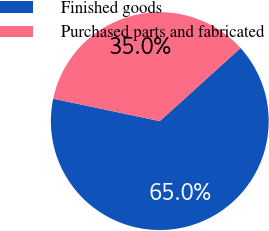Convert chart. <chart><loc_0><loc_0><loc_500><loc_500><pie_chart><fcel>Finished goods<fcel>Purchased parts and fabricated<nl><fcel>65.01%<fcel>34.99%<nl></chart> 